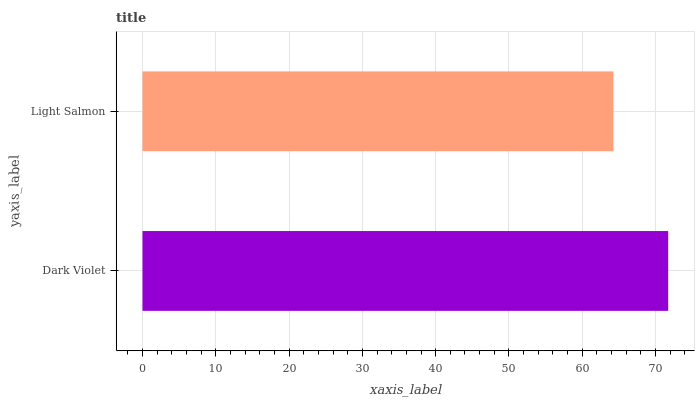Is Light Salmon the minimum?
Answer yes or no. Yes. Is Dark Violet the maximum?
Answer yes or no. Yes. Is Light Salmon the maximum?
Answer yes or no. No. Is Dark Violet greater than Light Salmon?
Answer yes or no. Yes. Is Light Salmon less than Dark Violet?
Answer yes or no. Yes. Is Light Salmon greater than Dark Violet?
Answer yes or no. No. Is Dark Violet less than Light Salmon?
Answer yes or no. No. Is Dark Violet the high median?
Answer yes or no. Yes. Is Light Salmon the low median?
Answer yes or no. Yes. Is Light Salmon the high median?
Answer yes or no. No. Is Dark Violet the low median?
Answer yes or no. No. 